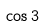Convert formula to latex. <formula><loc_0><loc_0><loc_500><loc_500>\cos 3</formula> 